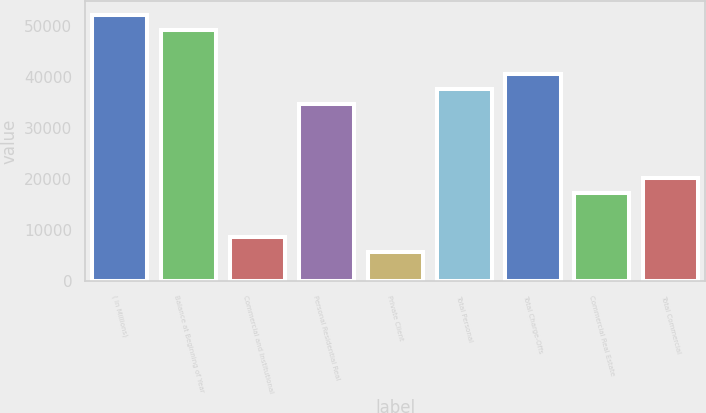Convert chart to OTSL. <chart><loc_0><loc_0><loc_500><loc_500><bar_chart><fcel>( in Millions)<fcel>Balance at Beginning of Year<fcel>Commercial and Institutional<fcel>Personal Residential Real<fcel>Private Client<fcel>Total Personal<fcel>Total Charge-Offs<fcel>Commercial Real Estate<fcel>Total Commercial<nl><fcel>52156.2<fcel>49258.6<fcel>8692.77<fcel>34770.8<fcel>5795.21<fcel>37668.4<fcel>40565.9<fcel>17385.5<fcel>20283<nl></chart> 